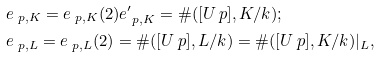Convert formula to latex. <formula><loc_0><loc_0><loc_500><loc_500>& e _ { \ p , K } = e _ { \ p , K } ( 2 ) e _ { \ p , K } ^ { \prime } = \# ( [ U _ { \ } p ] , K / k ) ; \\ & e _ { \ p , L } = e _ { \ p , L } ( 2 ) = \# ( [ U _ { \ } p ] , L / k ) = \# ( [ U _ { \ } p ] , K / k ) | _ { L } ,</formula> 